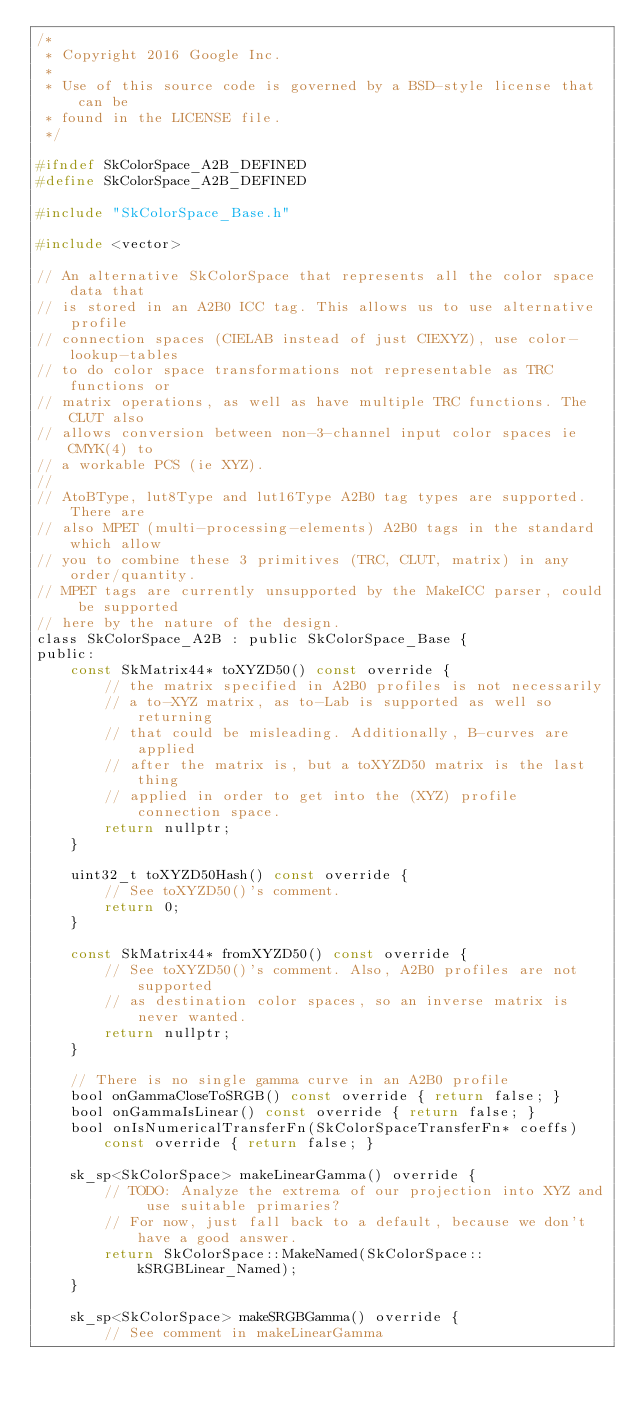<code> <loc_0><loc_0><loc_500><loc_500><_C_>/*
 * Copyright 2016 Google Inc.
 *
 * Use of this source code is governed by a BSD-style license that can be
 * found in the LICENSE file.
 */

#ifndef SkColorSpace_A2B_DEFINED
#define SkColorSpace_A2B_DEFINED

#include "SkColorSpace_Base.h"

#include <vector>

// An alternative SkColorSpace that represents all the color space data that
// is stored in an A2B0 ICC tag. This allows us to use alternative profile
// connection spaces (CIELAB instead of just CIEXYZ), use color-lookup-tables
// to do color space transformations not representable as TRC functions or
// matrix operations, as well as have multiple TRC functions. The CLUT also
// allows conversion between non-3-channel input color spaces ie CMYK(4) to
// a workable PCS (ie XYZ).
//
// AtoBType, lut8Type and lut16Type A2B0 tag types are supported. There are
// also MPET (multi-processing-elements) A2B0 tags in the standard which allow
// you to combine these 3 primitives (TRC, CLUT, matrix) in any order/quantity.
// MPET tags are currently unsupported by the MakeICC parser, could be supported
// here by the nature of the design.
class SkColorSpace_A2B : public SkColorSpace_Base {
public:
    const SkMatrix44* toXYZD50() const override {
        // the matrix specified in A2B0 profiles is not necessarily
        // a to-XYZ matrix, as to-Lab is supported as well so returning
        // that could be misleading. Additionally, B-curves are applied
        // after the matrix is, but a toXYZD50 matrix is the last thing
        // applied in order to get into the (XYZ) profile connection space.
        return nullptr;
    }

    uint32_t toXYZD50Hash() const override {
        // See toXYZD50()'s comment.
        return 0;
    }

    const SkMatrix44* fromXYZD50() const override {
        // See toXYZD50()'s comment. Also, A2B0 profiles are not supported
        // as destination color spaces, so an inverse matrix is never wanted.
        return nullptr;
    }

    // There is no single gamma curve in an A2B0 profile
    bool onGammaCloseToSRGB() const override { return false; }
    bool onGammaIsLinear() const override { return false; }
    bool onIsNumericalTransferFn(SkColorSpaceTransferFn* coeffs) const override { return false; }

    sk_sp<SkColorSpace> makeLinearGamma() override {
        // TODO: Analyze the extrema of our projection into XYZ and use suitable primaries?
        // For now, just fall back to a default, because we don't have a good answer.
        return SkColorSpace::MakeNamed(SkColorSpace::kSRGBLinear_Named);
    }

    sk_sp<SkColorSpace> makeSRGBGamma() override {
        // See comment in makeLinearGamma</code> 